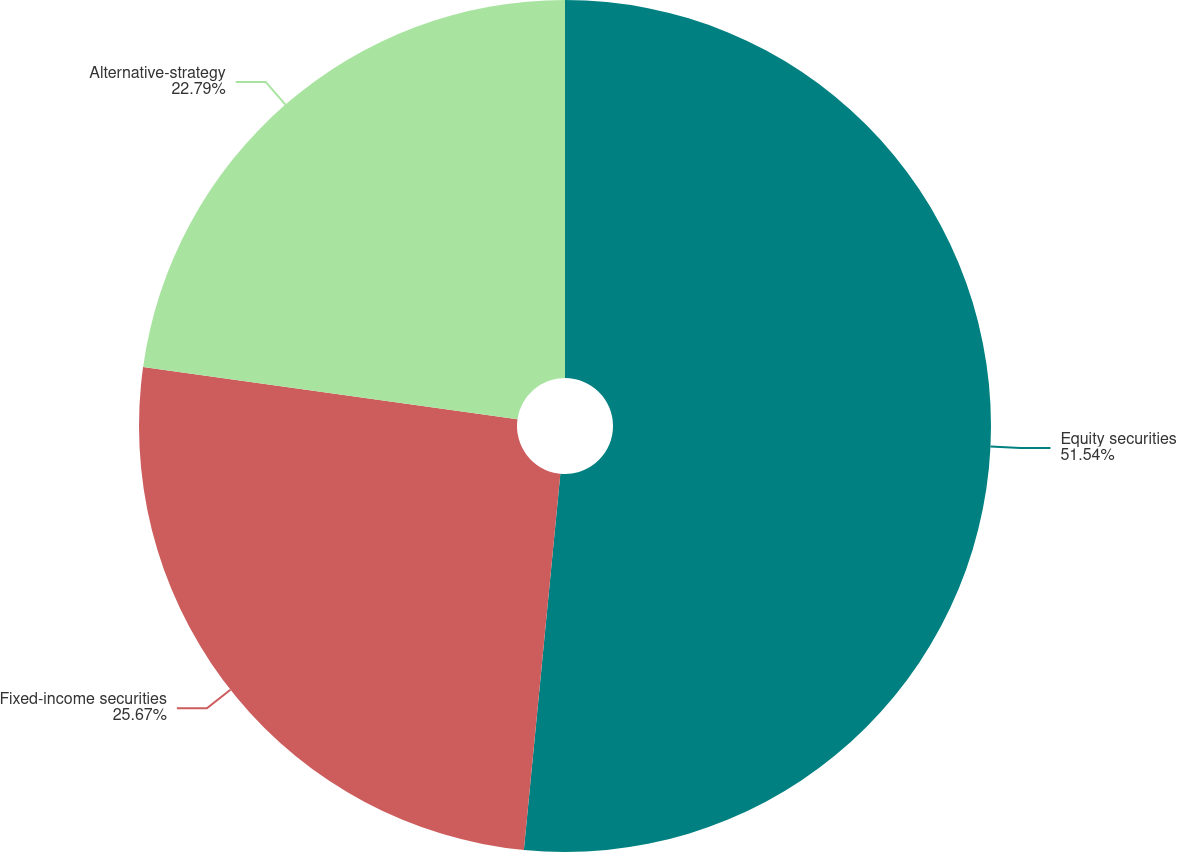<chart> <loc_0><loc_0><loc_500><loc_500><pie_chart><fcel>Equity securities<fcel>Fixed-income securities<fcel>Alternative-strategy<nl><fcel>51.54%<fcel>25.67%<fcel>22.79%<nl></chart> 